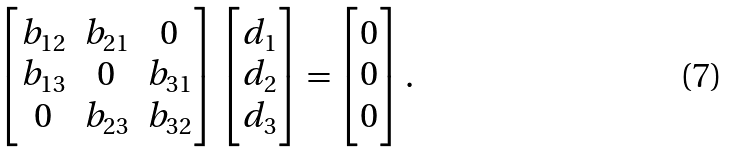<formula> <loc_0><loc_0><loc_500><loc_500>\begin{bmatrix} b _ { 1 2 } & b _ { 2 1 } & 0 \\ b _ { 1 3 } & 0 & b _ { 3 1 } \\ 0 & b _ { 2 3 } & b _ { 3 2 } \end{bmatrix} \begin{bmatrix} d _ { 1 } \\ d _ { 2 } \\ d _ { 3 } \end{bmatrix} = \begin{bmatrix} 0 \\ 0 \\ 0 \end{bmatrix} .</formula> 